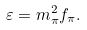<formula> <loc_0><loc_0><loc_500><loc_500>\varepsilon = m _ { \pi } ^ { 2 } f _ { \pi } .</formula> 